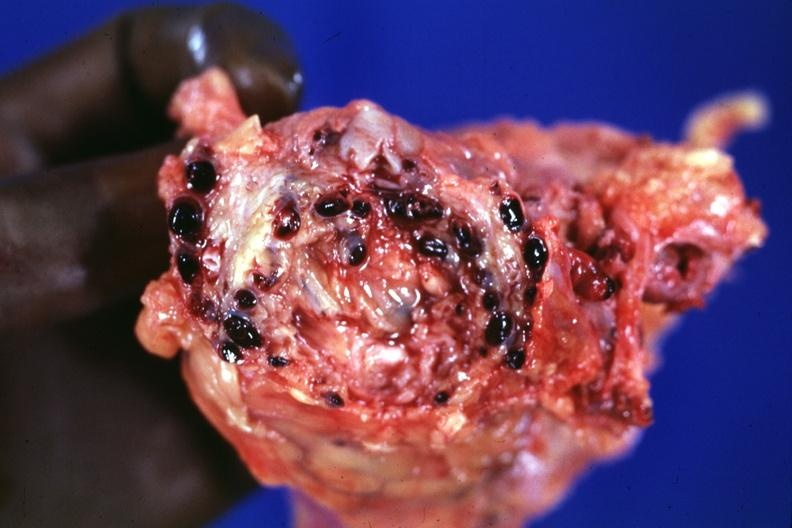s prostate present?
Answer the question using a single word or phrase. Yes 